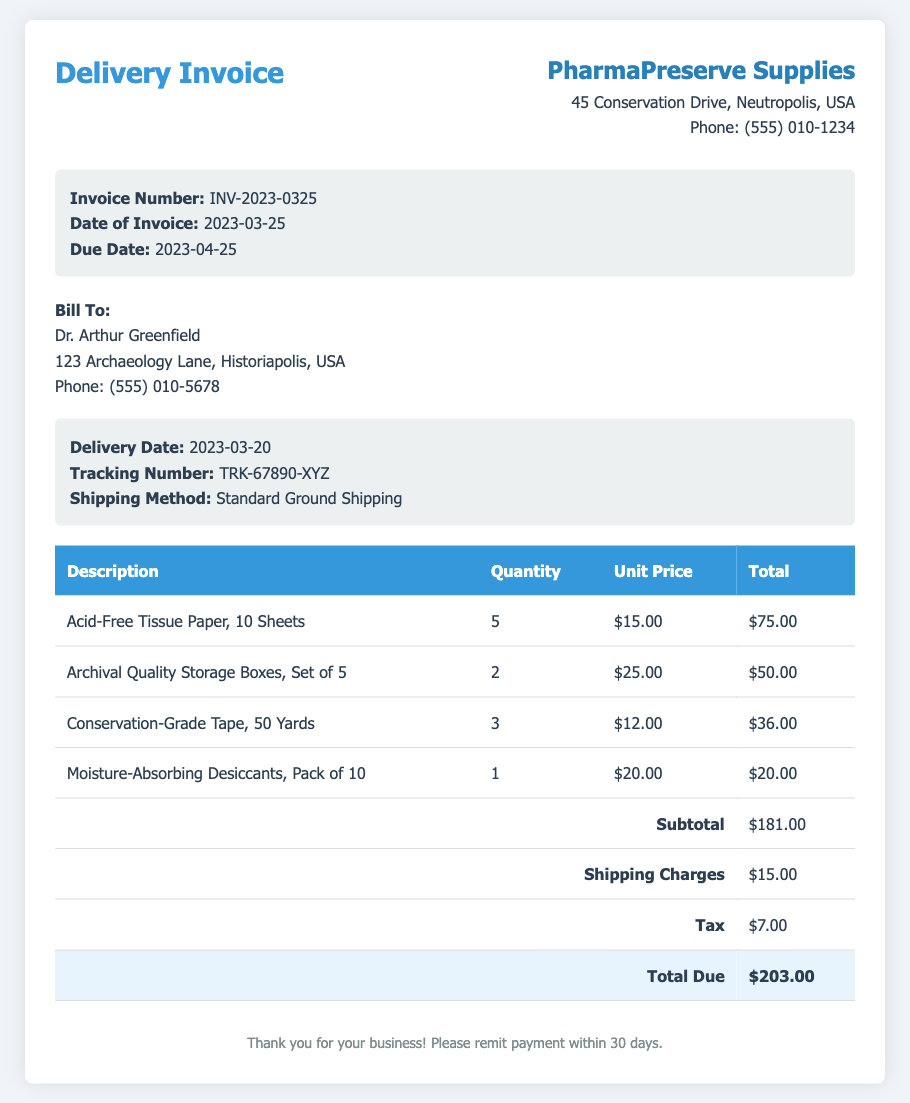What is the invoice number? The invoice number is specified in the document and is a unique identifier for this transaction.
Answer: INV-2023-0325 What is the date of the invoice? The date of the invoice is mentioned clearly on the document as the issuance date.
Answer: 2023-03-25 Who is the bill to? The name of the person being billed is explicitly mentioned in the customer details section.
Answer: Dr. Arthur Greenfield What is the subtotal amount? The subtotal is the sum of all item prices before adding shipping and tax, shown in the table.
Answer: $181.00 What are the shipping charges? The shipping charges are detailed within the costs section, indicating the expense incurred for delivery.
Answer: $15.00 What is the total amount due? The total amount due is the final sum calculated at the end of the invoice, encompassing all charges.
Answer: $203.00 What was the shipping method used? The shipping method is specified in the delivery information section of the document.
Answer: Standard Ground Shipping What is the due date for payment? The due date is noted in the invoice details, indicating when the payment is expected.
Answer: 2023-04-25 How many sheets of acid-free tissue paper were ordered? The quantity of the acid-free tissue paper is provided in the table under the respective product description.
Answer: 5 